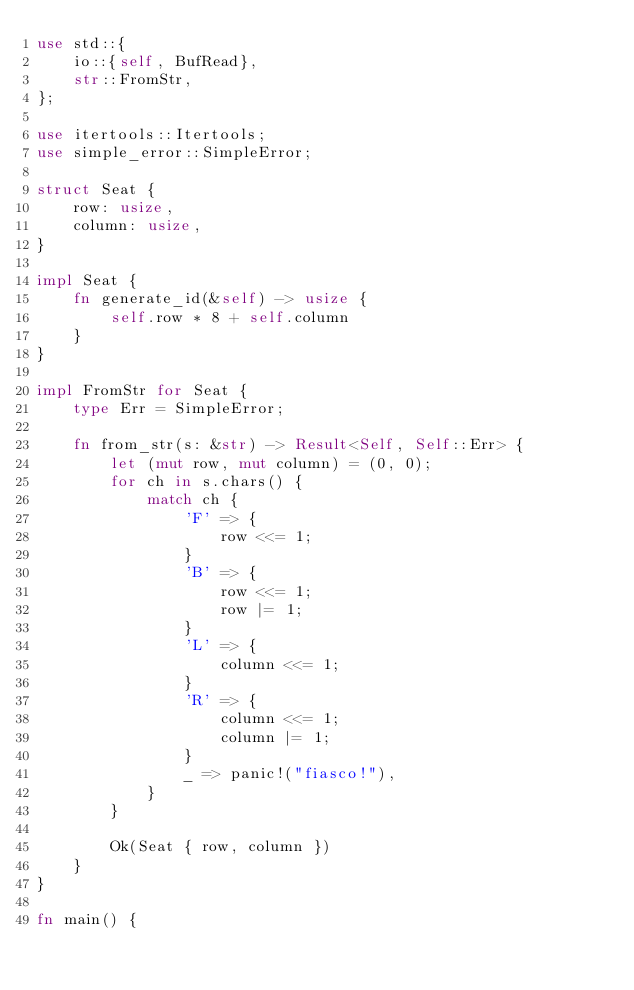<code> <loc_0><loc_0><loc_500><loc_500><_Rust_>use std::{
    io::{self, BufRead},
    str::FromStr,
};

use itertools::Itertools;
use simple_error::SimpleError;

struct Seat {
    row: usize,
    column: usize,
}

impl Seat {
    fn generate_id(&self) -> usize {
        self.row * 8 + self.column
    }
}

impl FromStr for Seat {
    type Err = SimpleError;

    fn from_str(s: &str) -> Result<Self, Self::Err> {
        let (mut row, mut column) = (0, 0);
        for ch in s.chars() {
            match ch {
                'F' => {
                    row <<= 1;
                }
                'B' => {
                    row <<= 1;
                    row |= 1;
                }
                'L' => {
                    column <<= 1;
                }
                'R' => {
                    column <<= 1;
                    column |= 1;
                }
                _ => panic!("fiasco!"),
            }
        }

        Ok(Seat { row, column })
    }
}

fn main() {</code> 